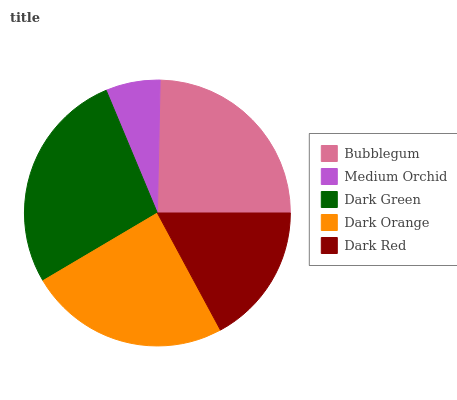Is Medium Orchid the minimum?
Answer yes or no. Yes. Is Dark Green the maximum?
Answer yes or no. Yes. Is Dark Green the minimum?
Answer yes or no. No. Is Medium Orchid the maximum?
Answer yes or no. No. Is Dark Green greater than Medium Orchid?
Answer yes or no. Yes. Is Medium Orchid less than Dark Green?
Answer yes or no. Yes. Is Medium Orchid greater than Dark Green?
Answer yes or no. No. Is Dark Green less than Medium Orchid?
Answer yes or no. No. Is Dark Orange the high median?
Answer yes or no. Yes. Is Dark Orange the low median?
Answer yes or no. Yes. Is Bubblegum the high median?
Answer yes or no. No. Is Bubblegum the low median?
Answer yes or no. No. 